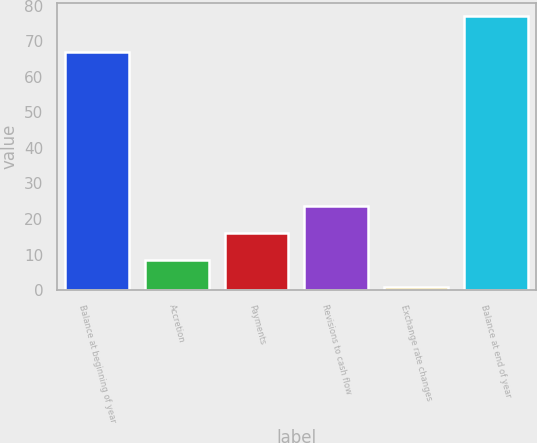<chart> <loc_0><loc_0><loc_500><loc_500><bar_chart><fcel>Balance at beginning of year<fcel>Accretion<fcel>Payments<fcel>Revisions to cash flow<fcel>Exchange rate changes<fcel>Balance at end of year<nl><fcel>67<fcel>8.6<fcel>16.2<fcel>23.8<fcel>1<fcel>77<nl></chart> 